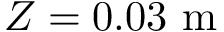<formula> <loc_0><loc_0><loc_500><loc_500>Z = 0 . 0 3 m</formula> 